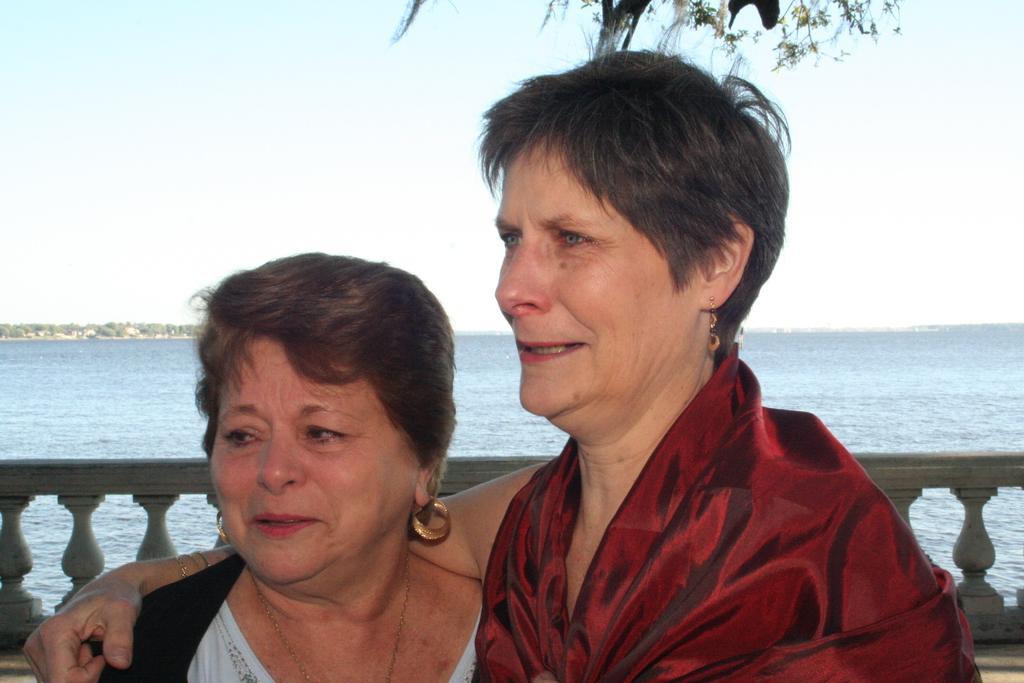Can you describe this image briefly? In this image we can see two persons, there is a wall, water, few trees and the sky in the background. 